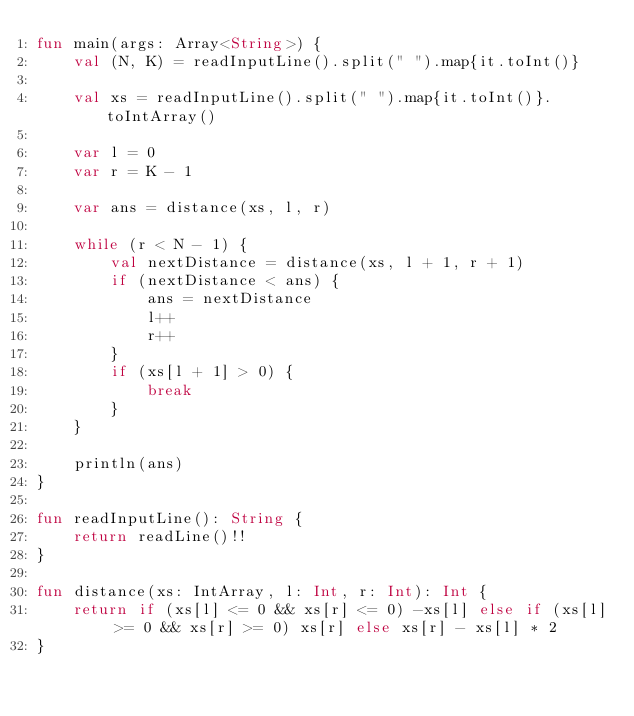Convert code to text. <code><loc_0><loc_0><loc_500><loc_500><_Kotlin_>fun main(args: Array<String>) {
    val (N, K) = readInputLine().split(" ").map{it.toInt()}
    
    val xs = readInputLine().split(" ").map{it.toInt()}.toIntArray()
    
    var l = 0
    var r = K - 1
    
    var ans = distance(xs, l, r)

    while (r < N - 1) {
        val nextDistance = distance(xs, l + 1, r + 1)
        if (nextDistance < ans) {
            ans = nextDistance
            l++
            r++
        }
        if (xs[l + 1] > 0) {
            break
        }
    }
    
    println(ans)
}

fun readInputLine(): String {
    return readLine()!!
}

fun distance(xs: IntArray, l: Int, r: Int): Int {
    return if (xs[l] <= 0 && xs[r] <= 0) -xs[l] else if (xs[l] >= 0 && xs[r] >= 0) xs[r] else xs[r] - xs[l] * 2
}
</code> 